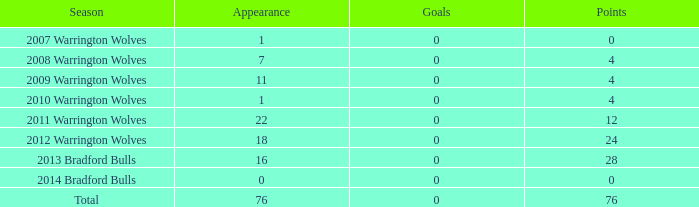In how many cases are attempts 0 and appearance negative? 0.0. 